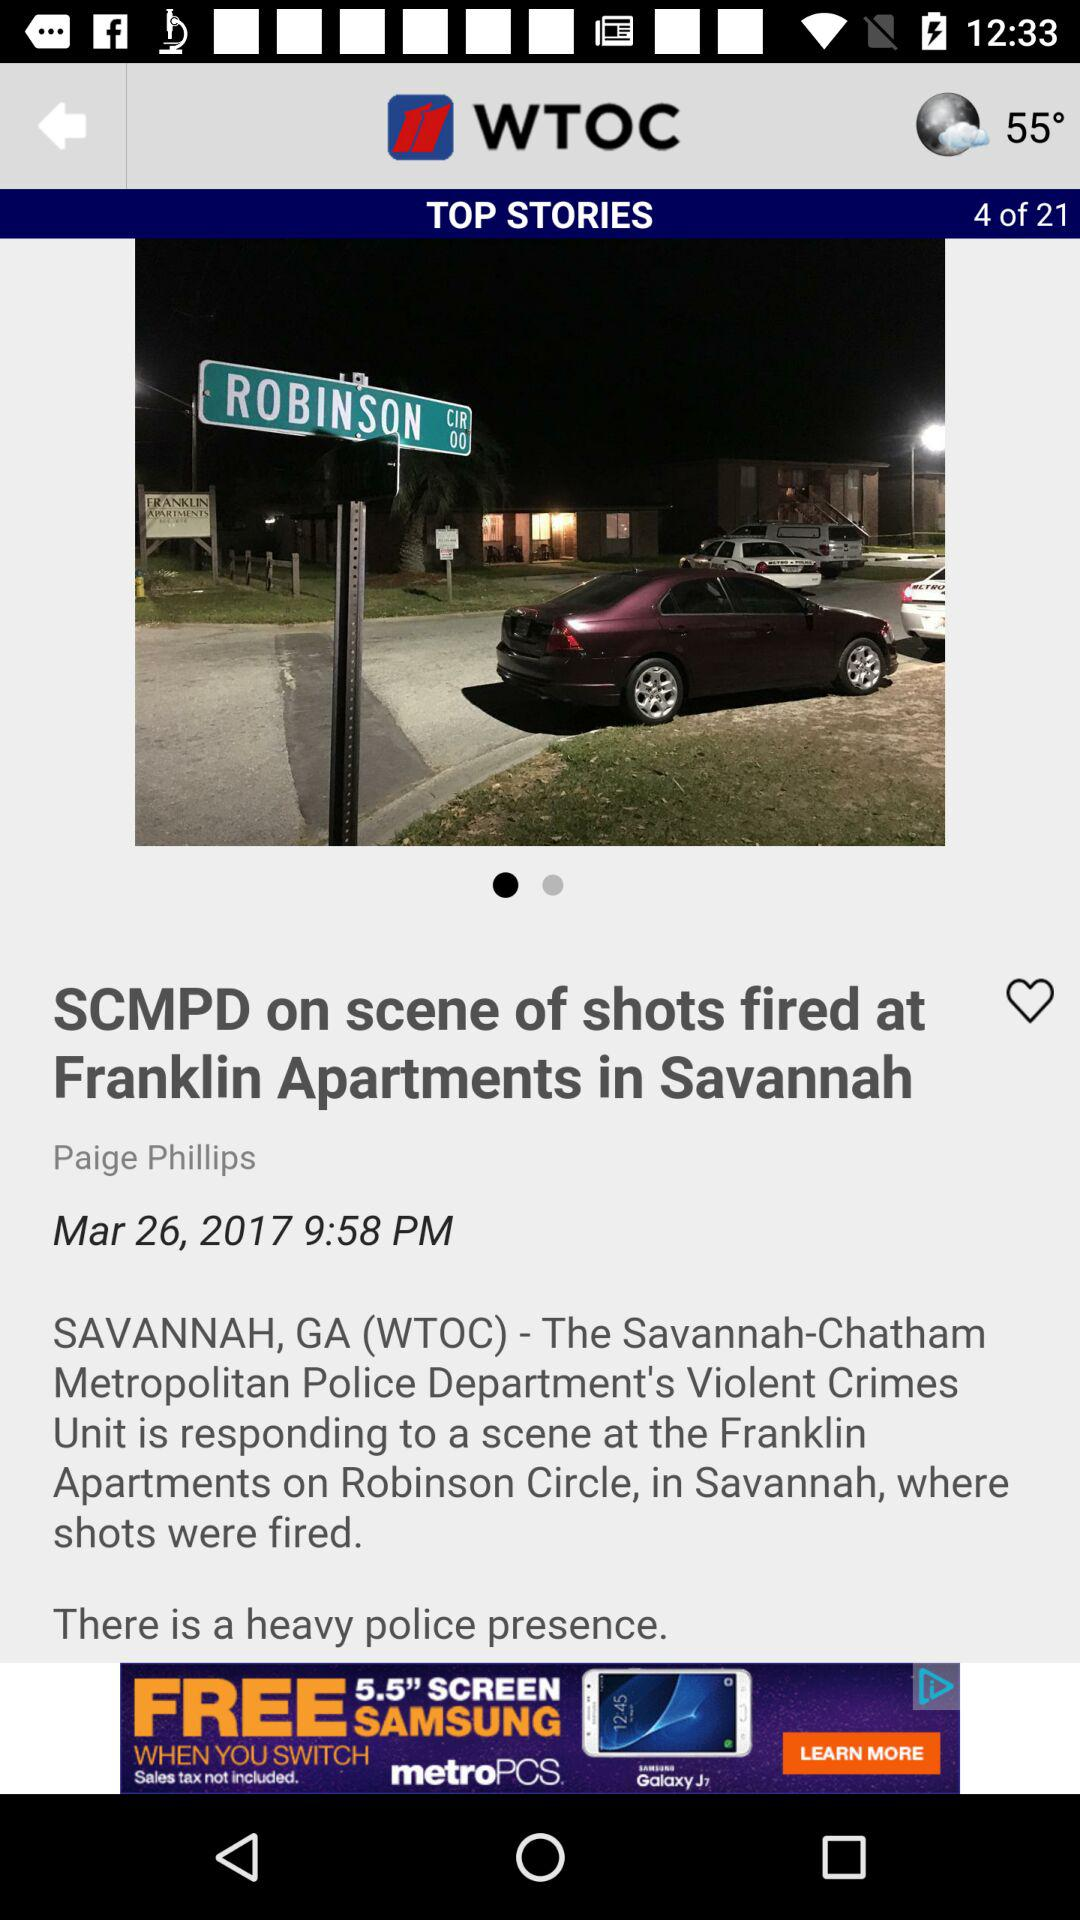How many more stories are there after the current story than before it?
Answer the question using a single word or phrase. 17 